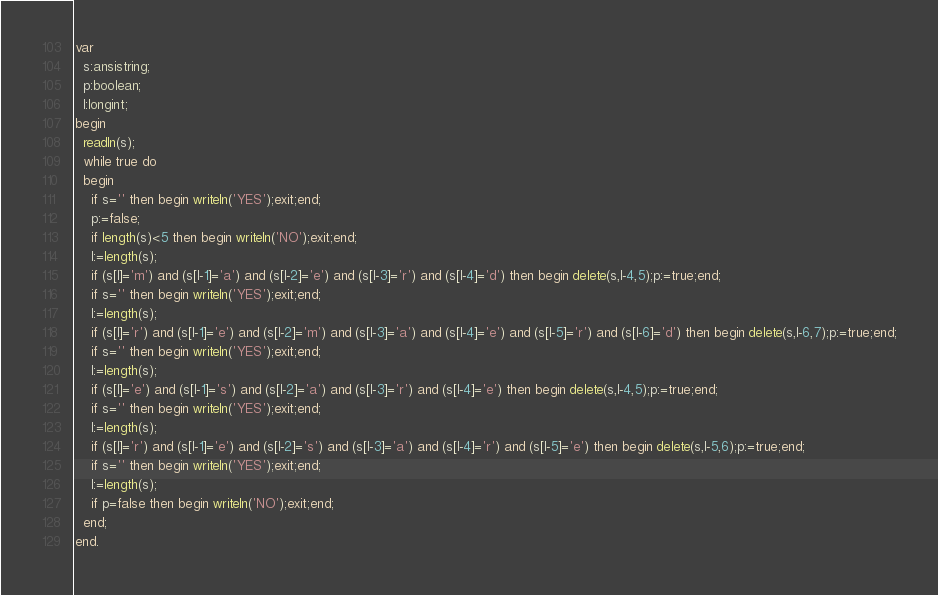<code> <loc_0><loc_0><loc_500><loc_500><_Pascal_>var
  s:ansistring;
  p:boolean;
  l:longint;
begin
  readln(s);
  while true do
  begin
    if s='' then begin writeln('YES');exit;end;
    p:=false;
    if length(s)<5 then begin writeln('NO');exit;end;
    l:=length(s);
    if (s[l]='m') and (s[l-1]='a') and (s[l-2]='e') and (s[l-3]='r') and (s[l-4]='d') then begin delete(s,l-4,5);p:=true;end;
    if s='' then begin writeln('YES');exit;end;
    l:=length(s);
    if (s[l]='r') and (s[l-1]='e') and (s[l-2]='m') and (s[l-3]='a') and (s[l-4]='e') and (s[l-5]='r') and (s[l-6]='d') then begin delete(s,l-6,7);p:=true;end;
    if s='' then begin writeln('YES');exit;end;
    l:=length(s);
    if (s[l]='e') and (s[l-1]='s') and (s[l-2]='a') and (s[l-3]='r') and (s[l-4]='e') then begin delete(s,l-4,5);p:=true;end;
    if s='' then begin writeln('YES');exit;end;
    l:=length(s);
    if (s[l]='r') and (s[l-1]='e') and (s[l-2]='s') and (s[l-3]='a') and (s[l-4]='r') and (s[l-5]='e') then begin delete(s,l-5,6);p:=true;end;
    if s='' then begin writeln('YES');exit;end;
    l:=length(s);
    if p=false then begin writeln('NO');exit;end;
  end;
end.
</code> 